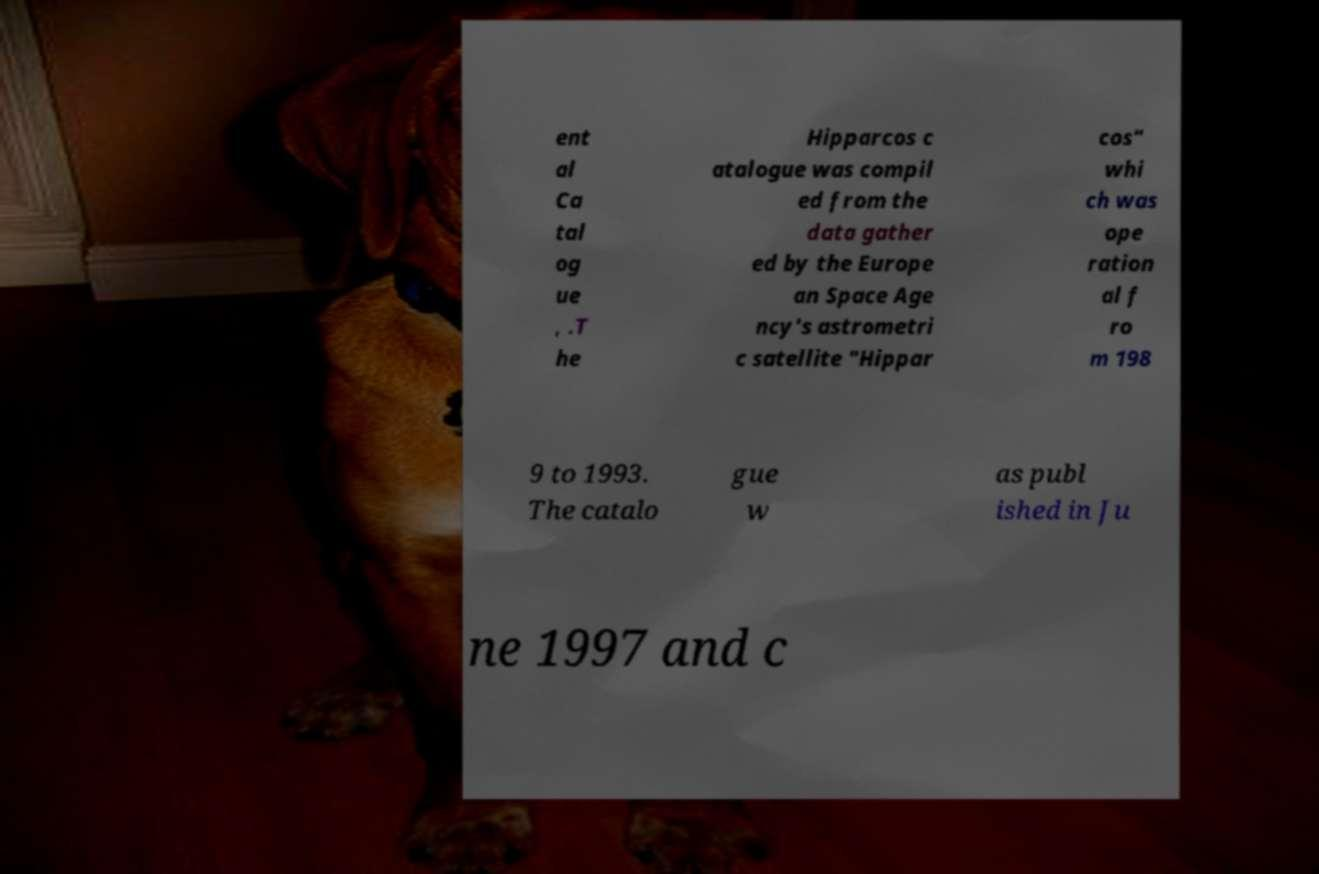Please read and relay the text visible in this image. What does it say? ent al Ca tal og ue , .T he Hipparcos c atalogue was compil ed from the data gather ed by the Europe an Space Age ncy's astrometri c satellite "Hippar cos" whi ch was ope ration al f ro m 198 9 to 1993. The catalo gue w as publ ished in Ju ne 1997 and c 